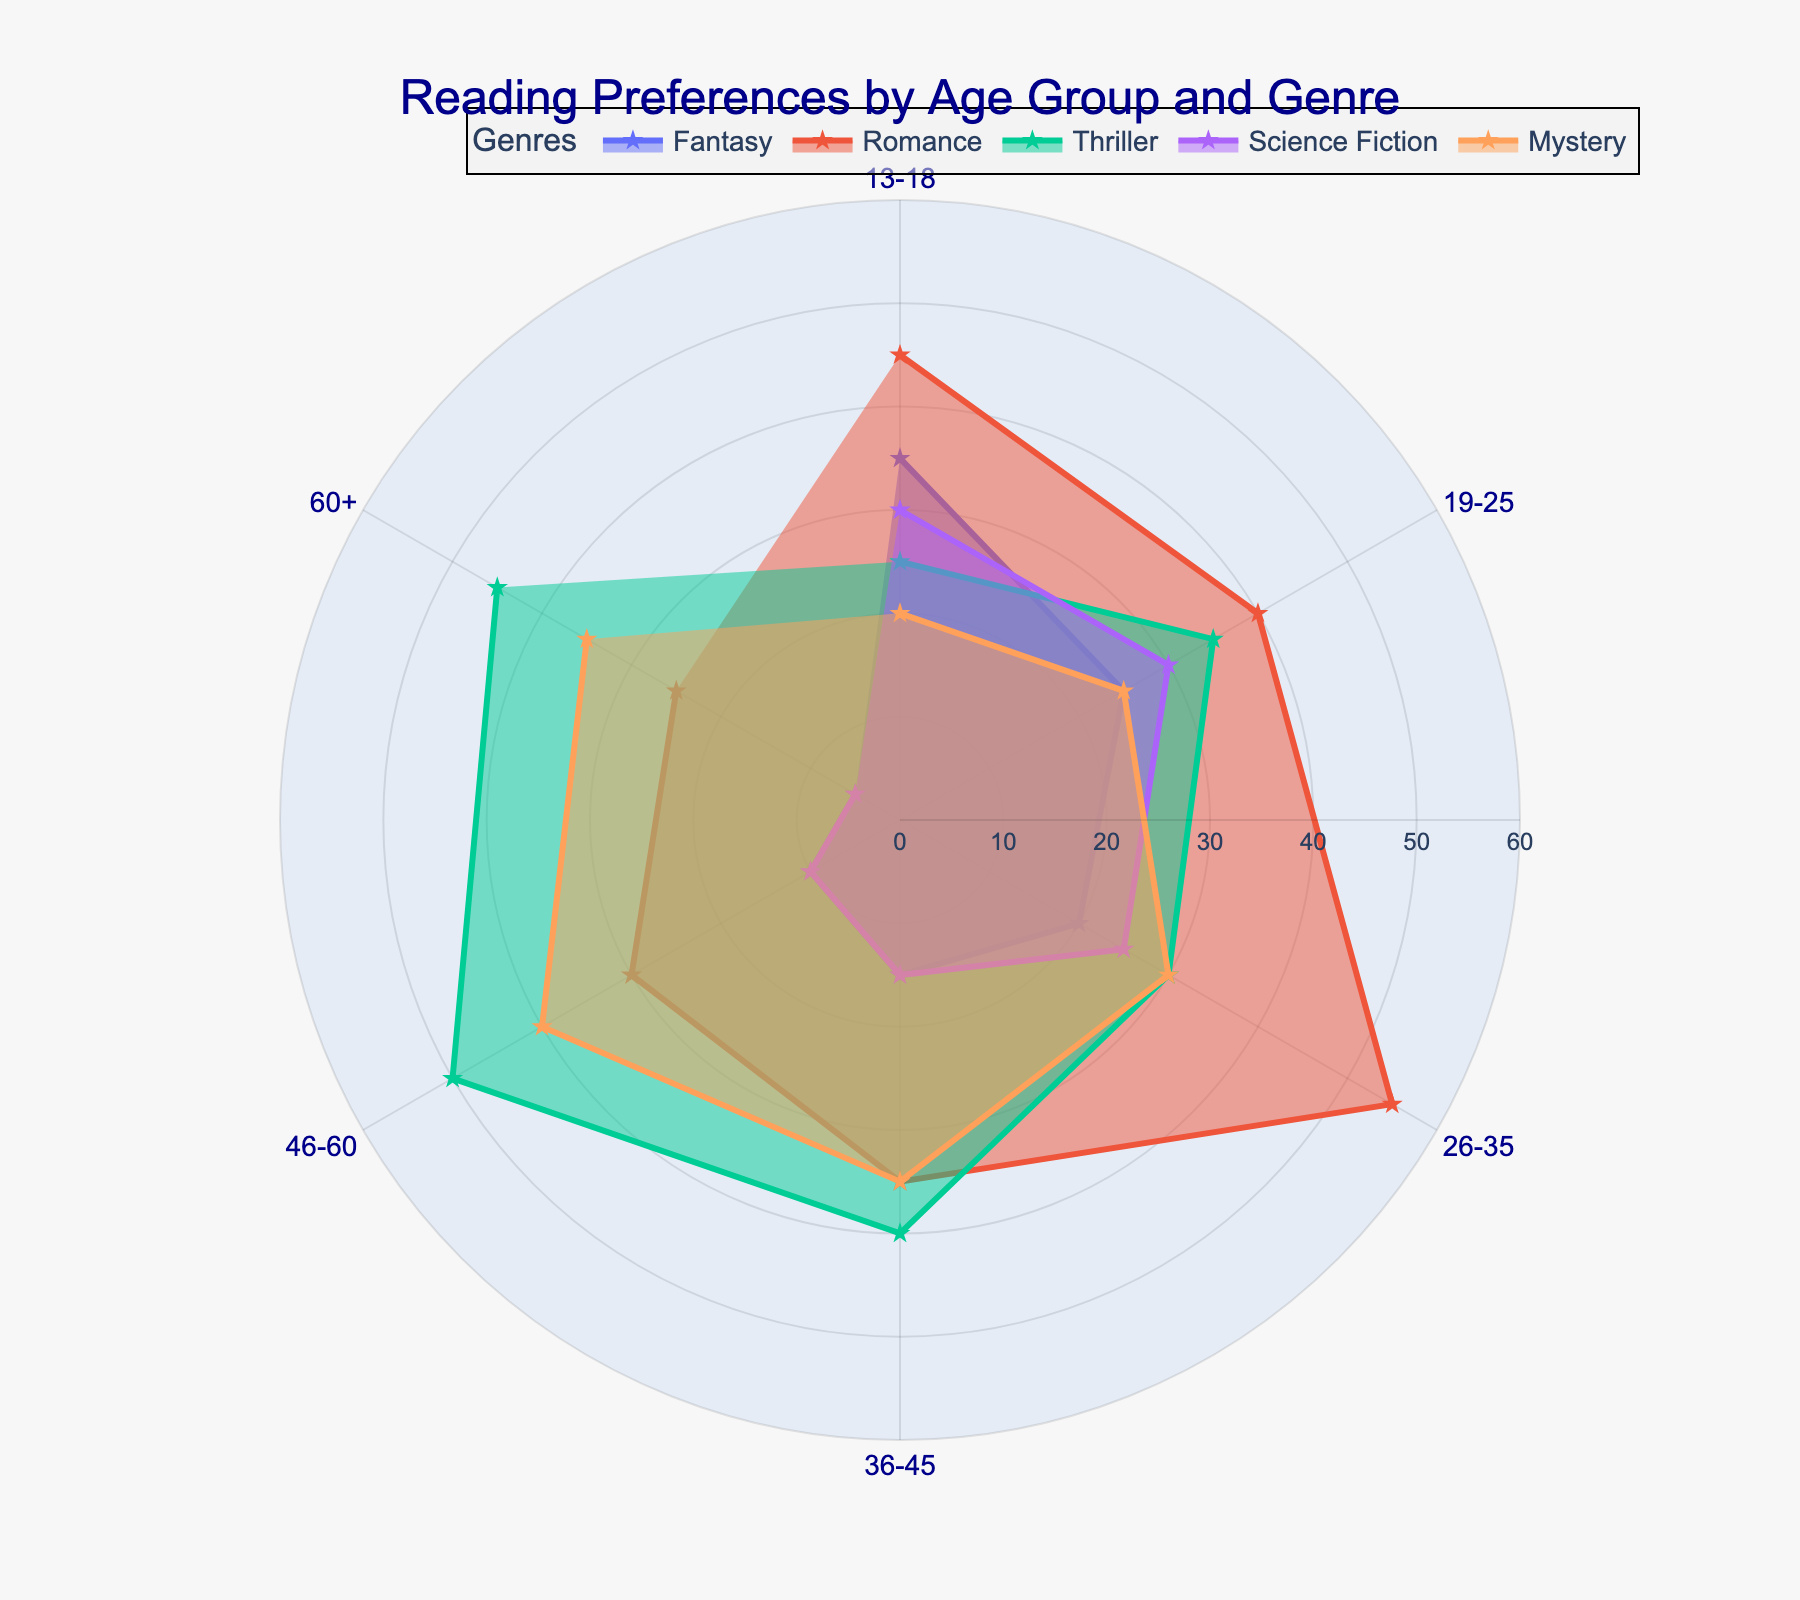What is the title of the plot? The title of the plot is usually located at the top center, where it conveys the main subject of the plot.
Answer: Reading Preferences by Age Group and Genre Which age group shows the highest preference for Romance? To find the highest preference for Romance, look for the data point where the Romance line (typically marked with a different color or pattern) peaks.
Answer: 26-35 What genre has the lowest preference among the 13-18 age group? Look for the smallest value in the 13-18 age group row. Compare the values across all the genres.
Answer: Mystery Compare the preference for Thriller between the 46-60 age group and the 60+ age group. Which group prefers it more? Locate the Thriller values for both age groups and see which number is higher.
Answer: 46-60 Which genres have roughly equal preferences in the 19-25 age group? Check the values in the 19-25 age group row and identify the genres with similar values. For example, Fantasy and Science Fiction both have a preference of 30.
Answer: Fantasy and Science Fiction What is the range of preference values for Science Fiction across all age groups? Find the minimum and maximum values of Science Fiction across all age groups and subtract the minimum from the maximum.
Answer: 30 For which age group is Fantasy the least preferred genre? Find the smallest value in the Fantasy column and note the corresponding age group.
Answer: 60+ How does the preference for Mystery change from the 36-45 age group to the 46-60 age group? Compare the values of Mystery for these two age groups. Subtract the 36-45 value from the 46-60 value.
Answer: Increases by 5 Which age group shows the most balanced preferences across all genres? Identify the age group where the values across all genres are most similar, indicating a lack of a strong peak in any one genre.
Answer: 19-25 